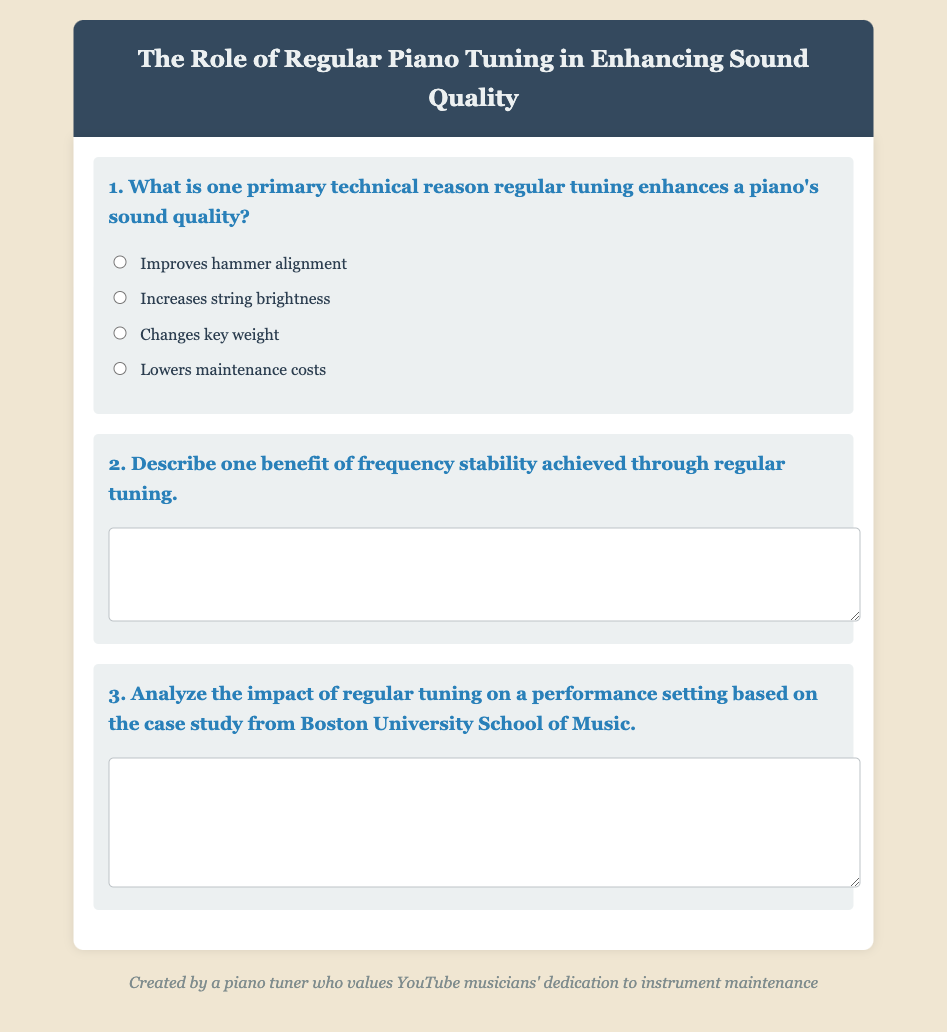What is the title of the document? The title of the document is indicated in the header section, stating the main topic of the exam.
Answer: The Role of Regular Piano Tuning in Enhancing Sound Quality How many questions are in the exam? The number of questions can be inferred from the document structure, as each question is contained within its own section.
Answer: 3 What color is the header background? The color of the header background can be identified from the style rules specified in the document.
Answer: Dark blue What is one of the primary options for question one? The primary options for question one are listed under the available answers in the exam section.
Answer: Improves hammer alignment Describe the expected response format for question two. The response format for question two consists of a designated area for longer textual answers, specifically a textarea element.
Answer: Textarea What phrase is used in the footer? The footer contains a statement that reflects the creator's identity and purpose.
Answer: Created by a piano tuner who values YouTube musicians' dedication to instrument maintenance What type of analysis does question three require? Question three specifically asks for a type of analysis related to a particular context provided in the document.
Answer: Case study analysis What color is used for headings in the questions? The color specified for headings in the questions is mentioned in the style section of the document.
Answer: Blue 